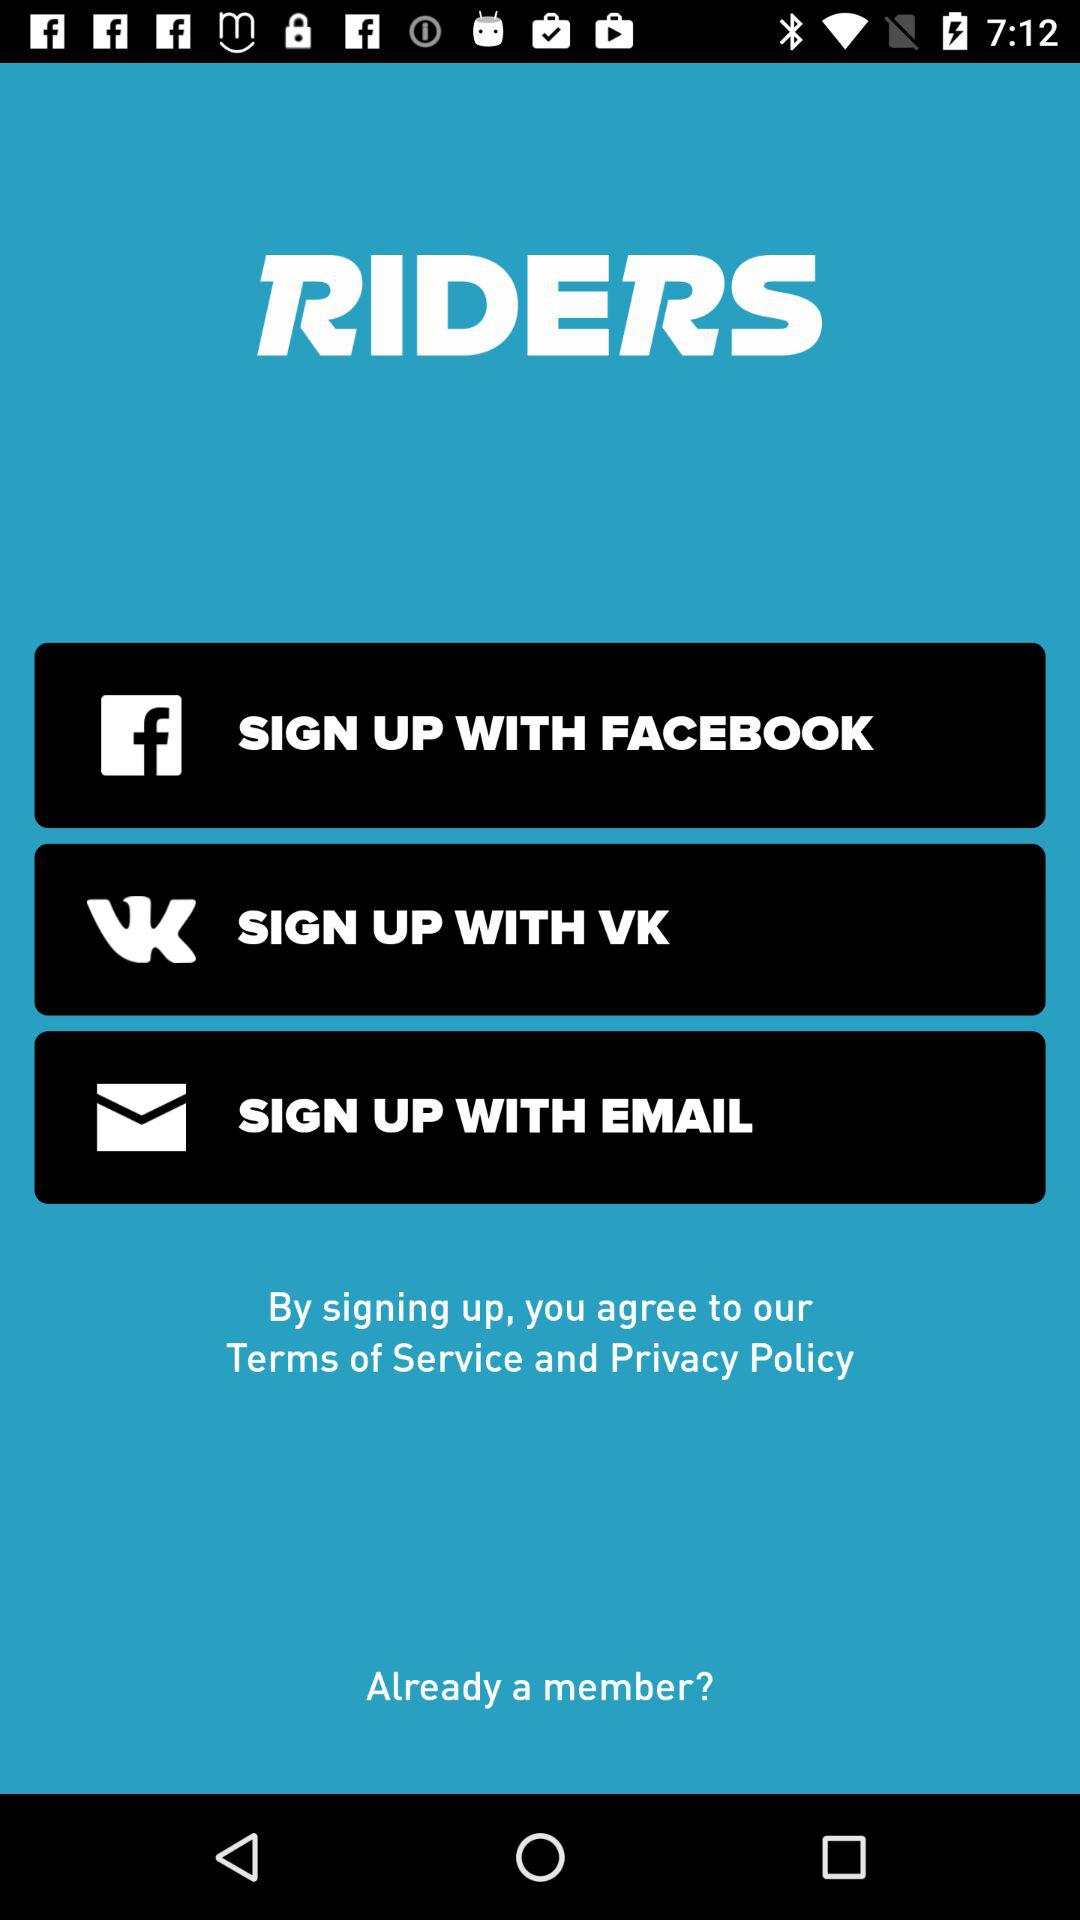What accounts can I use to sign up? You can use a "FACEBOOK", "VK" or "EMAIL" account to sign up. 